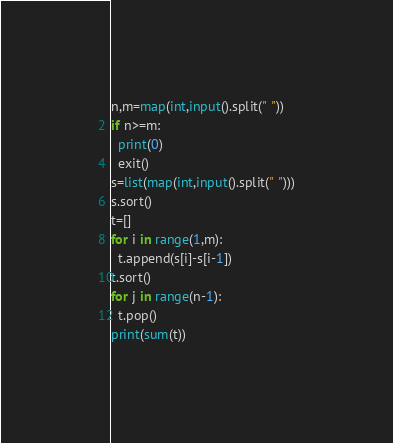<code> <loc_0><loc_0><loc_500><loc_500><_Python_>n,m=map(int,input().split(" "))
if n>=m:
  print(0)
  exit()
s=list(map(int,input().split(" ")))
s.sort()
t=[]
for i in range(1,m):
  t.append(s[i]-s[i-1])
t.sort()
for j in range(n-1):
  t.pop() 
print(sum(t))  </code> 